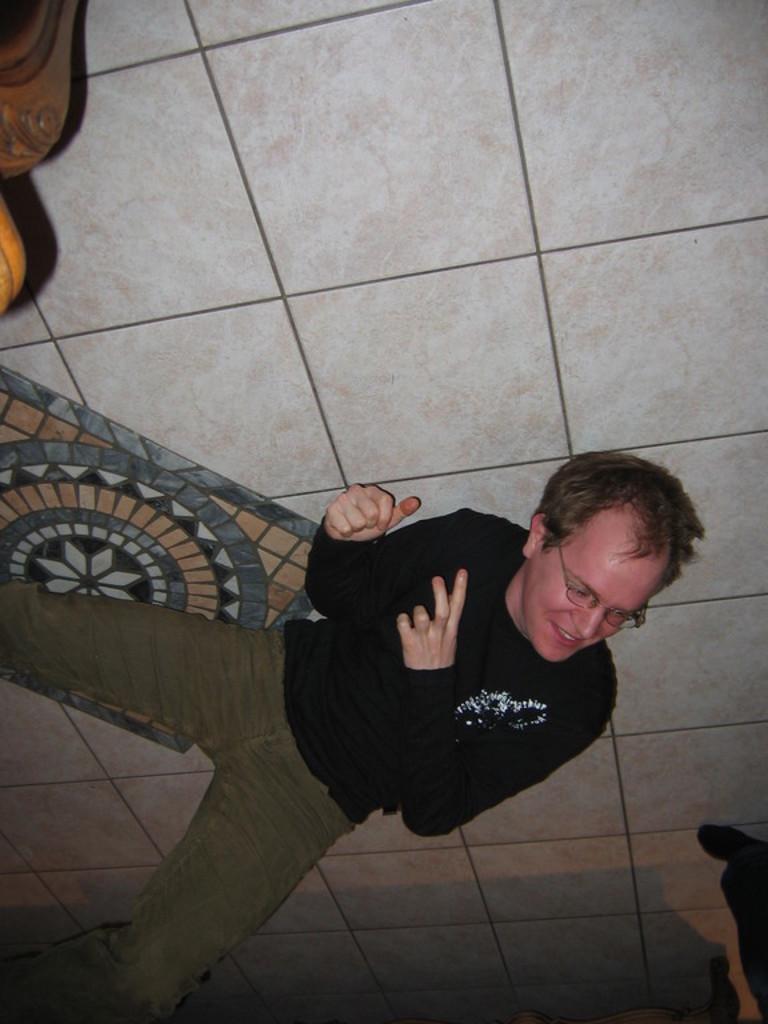Can you describe this image briefly? In this image, we can see a person lying on the floor. We can also see some object in the top left corner. 